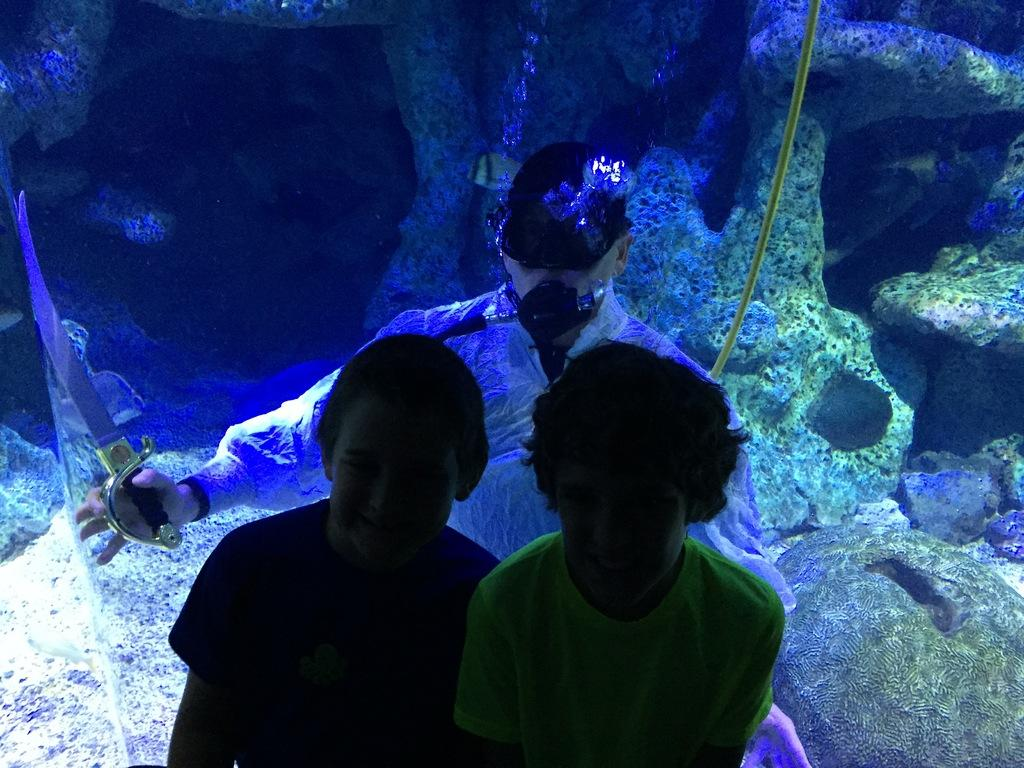How many kids are present in the image? There are two kids standing in the image. What is the man in the image doing? The man is in the water in the image. What can be seen in the water besides the man? There are stones visible in the water in the image. Is it raining or snowing in the image? There is no indication of rain or snow in the image. 